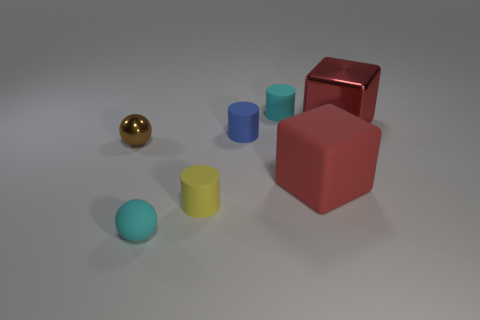How many red cubes must be subtracted to get 1 red cubes? 1 Subtract all brown balls. How many balls are left? 1 Add 1 big red metal blocks. How many objects exist? 8 Subtract all spheres. How many objects are left? 5 Subtract 1 balls. How many balls are left? 1 Subtract all gray cubes. Subtract all blue cylinders. How many cubes are left? 2 Subtract all green cylinders. How many green balls are left? 0 Subtract all rubber spheres. Subtract all big red matte blocks. How many objects are left? 5 Add 1 small cyan matte balls. How many small cyan matte balls are left? 2 Add 3 rubber objects. How many rubber objects exist? 8 